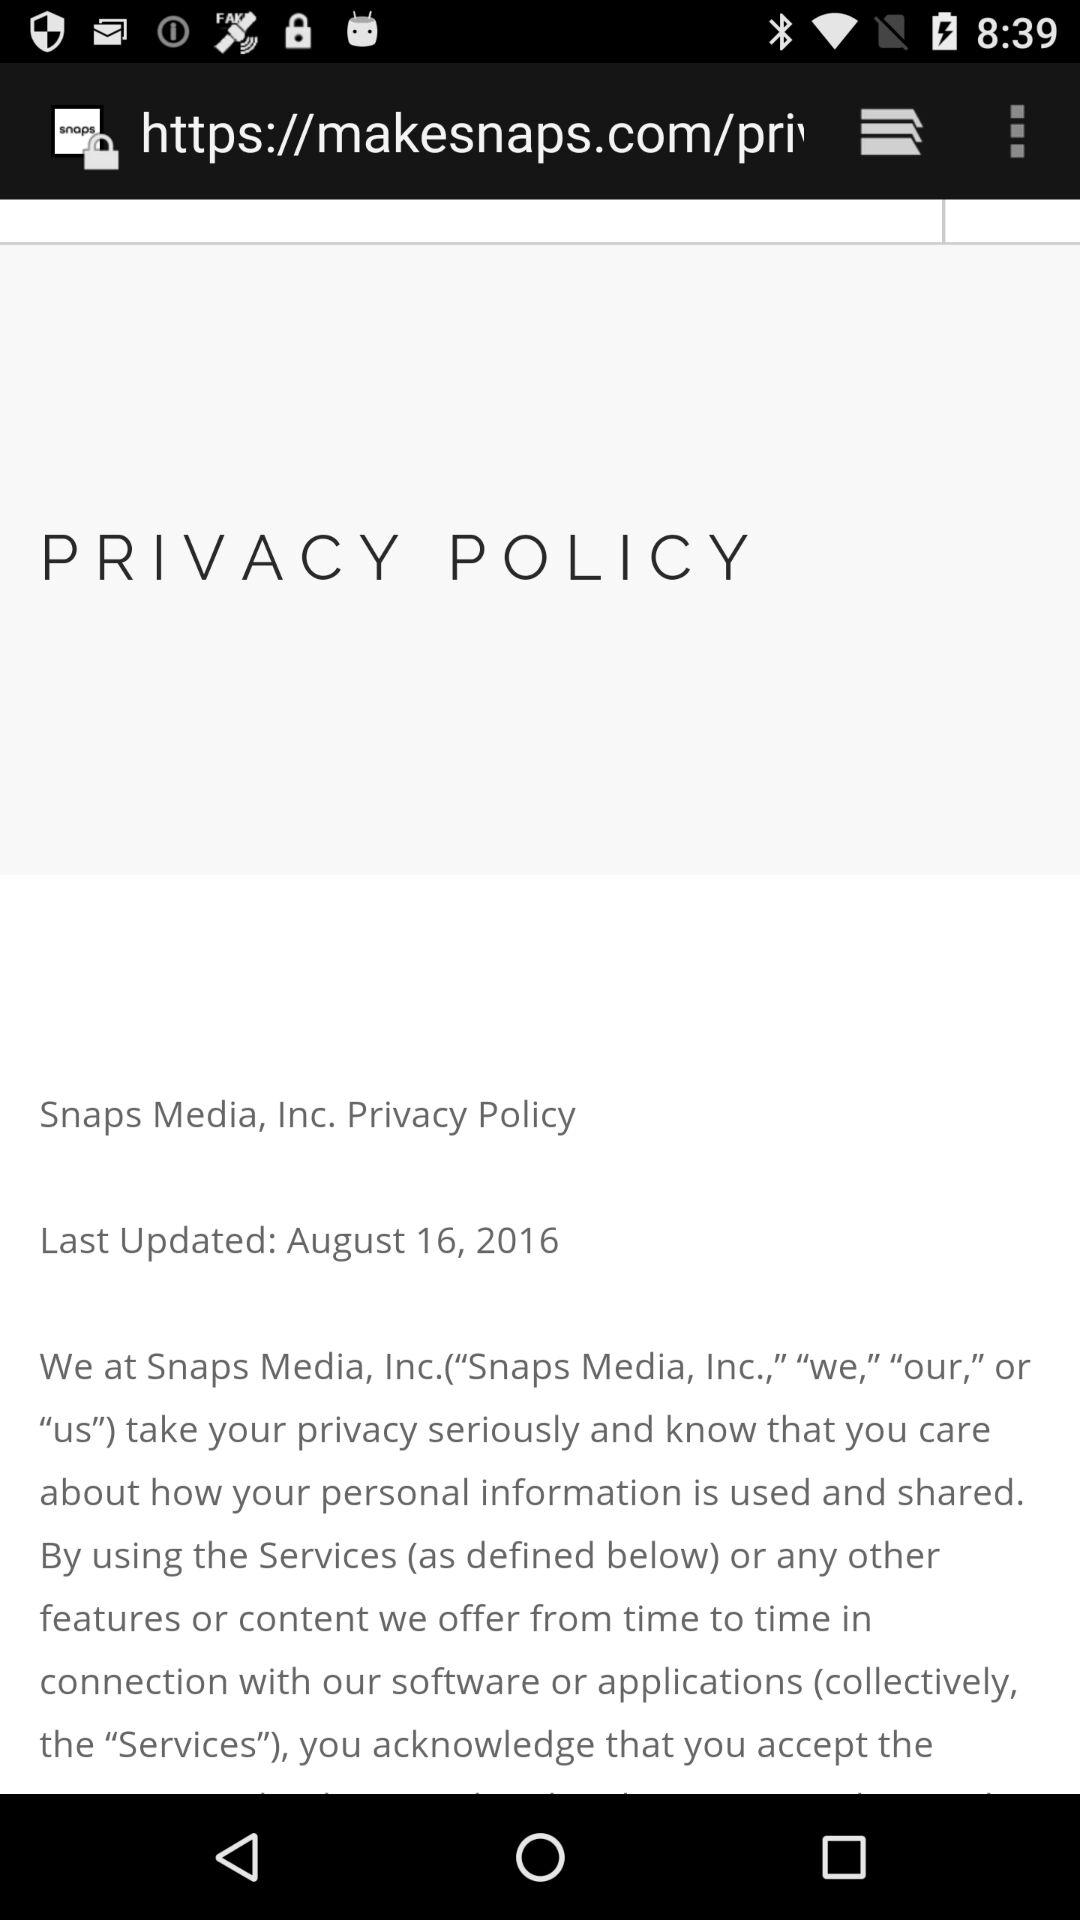What is the updated date of the policy? The policy update date is August 16, 2016. 